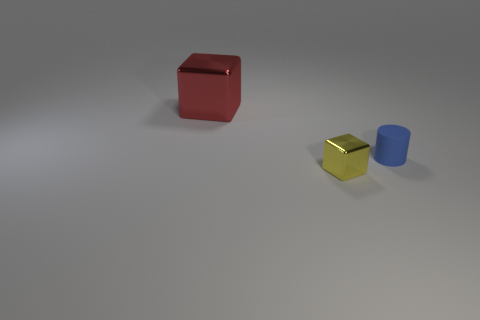What number of other objects are the same shape as the small blue matte thing?
Provide a succinct answer. 0. Are there any other things that have the same color as the tiny metal cube?
Ensure brevity in your answer.  No. What shape is the tiny rubber object that is right of the shiny object that is left of the yellow block?
Your response must be concise. Cylinder. Is the number of cubes greater than the number of small yellow cubes?
Make the answer very short. Yes. What number of blocks are in front of the rubber object and to the left of the tiny yellow thing?
Give a very brief answer. 0. There is a metallic cube on the right side of the large red shiny object; what number of large red objects are behind it?
Give a very brief answer. 1. What number of objects are blocks left of the small yellow metal thing or blocks behind the small matte thing?
Your answer should be compact. 1. There is a big red object that is the same shape as the small yellow shiny object; what is it made of?
Keep it short and to the point. Metal. How many objects are metal blocks behind the tiny blue thing or tiny blue cylinders?
Offer a terse response. 2. There is a red object that is the same material as the yellow block; what is its shape?
Keep it short and to the point. Cube. 